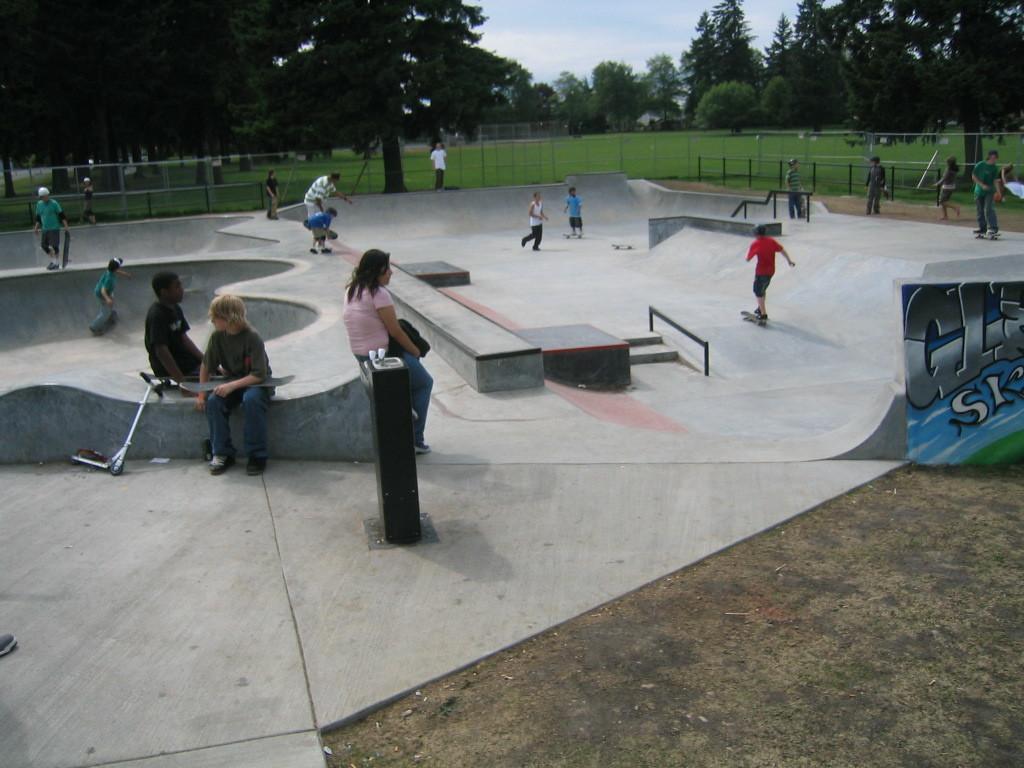How would you summarize this image in a sentence or two? In the picture we can see a play surface with some children are skating and some are running and around it we can see a railing and behind it, we can see a tree and in the background we can see full of trees and we can see a part of the sky. 